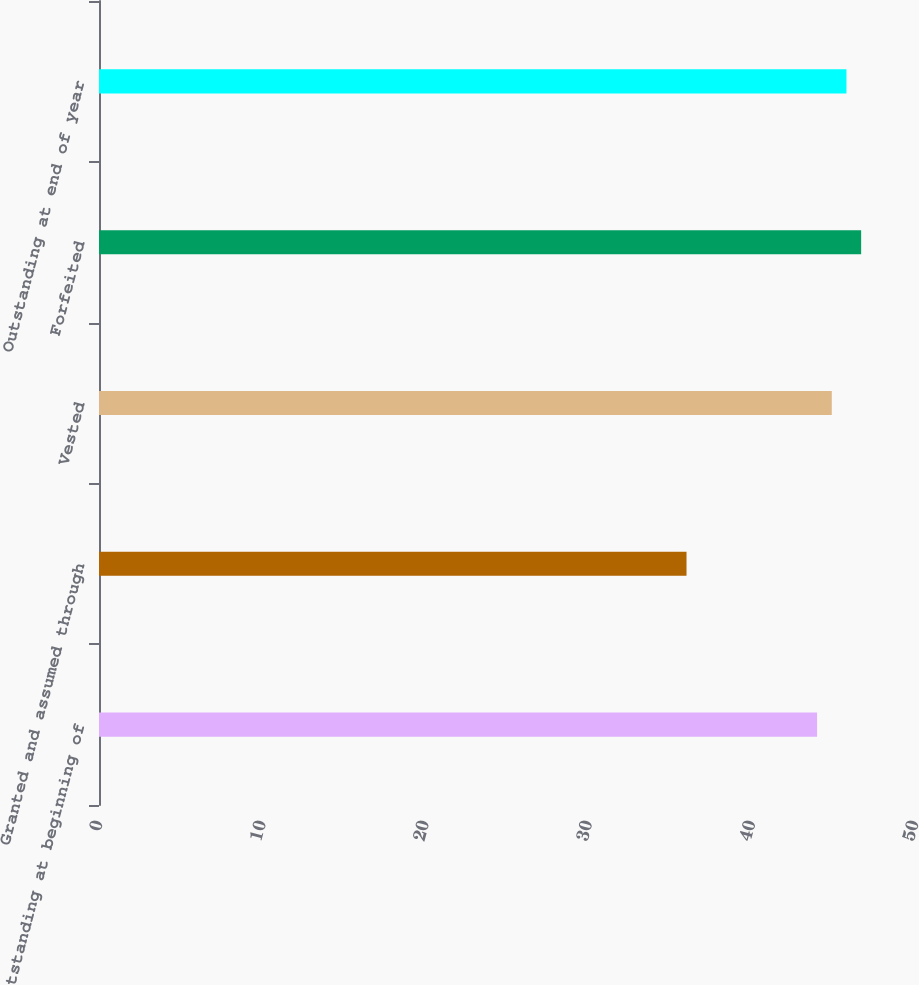Convert chart. <chart><loc_0><loc_0><loc_500><loc_500><bar_chart><fcel>Outstanding at beginning of<fcel>Granted and assumed through<fcel>Vested<fcel>Forfeited<fcel>Outstanding at end of year<nl><fcel>44<fcel>36<fcel>44.9<fcel>46.7<fcel>45.8<nl></chart> 